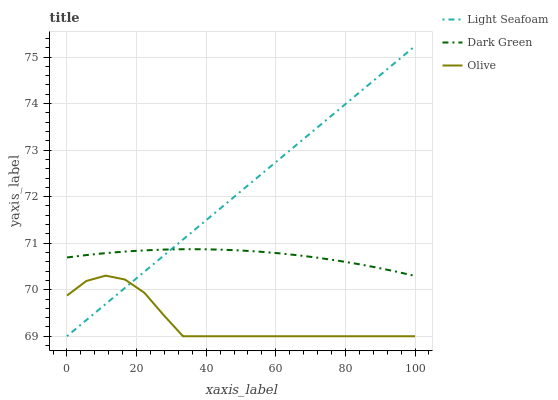Does Olive have the minimum area under the curve?
Answer yes or no. Yes. Does Light Seafoam have the maximum area under the curve?
Answer yes or no. Yes. Does Dark Green have the minimum area under the curve?
Answer yes or no. No. Does Dark Green have the maximum area under the curve?
Answer yes or no. No. Is Light Seafoam the smoothest?
Answer yes or no. Yes. Is Olive the roughest?
Answer yes or no. Yes. Is Dark Green the smoothest?
Answer yes or no. No. Is Dark Green the roughest?
Answer yes or no. No. Does Olive have the lowest value?
Answer yes or no. Yes. Does Dark Green have the lowest value?
Answer yes or no. No. Does Light Seafoam have the highest value?
Answer yes or no. Yes. Does Dark Green have the highest value?
Answer yes or no. No. Is Olive less than Dark Green?
Answer yes or no. Yes. Is Dark Green greater than Olive?
Answer yes or no. Yes. Does Light Seafoam intersect Dark Green?
Answer yes or no. Yes. Is Light Seafoam less than Dark Green?
Answer yes or no. No. Is Light Seafoam greater than Dark Green?
Answer yes or no. No. Does Olive intersect Dark Green?
Answer yes or no. No. 